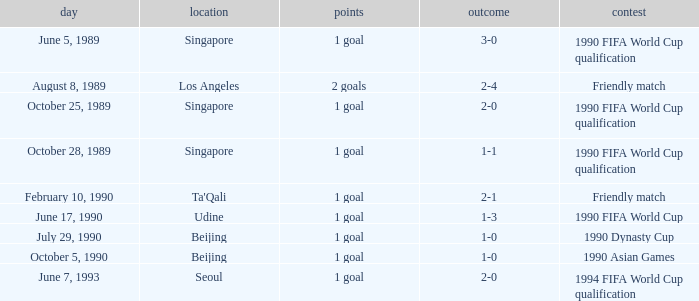What is the competition at the ta'qali venue? Friendly match. 